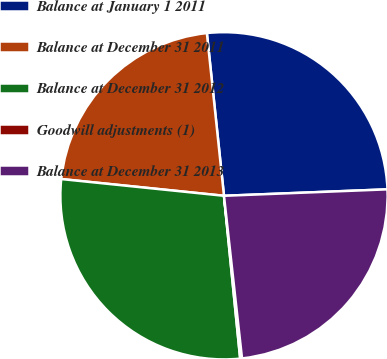Convert chart. <chart><loc_0><loc_0><loc_500><loc_500><pie_chart><fcel>Balance at January 1 2011<fcel>Balance at December 31 2011<fcel>Balance at December 31 2012<fcel>Goodwill adjustments (1)<fcel>Balance at December 31 2013<nl><fcel>26.04%<fcel>21.7%<fcel>28.21%<fcel>0.18%<fcel>23.87%<nl></chart> 